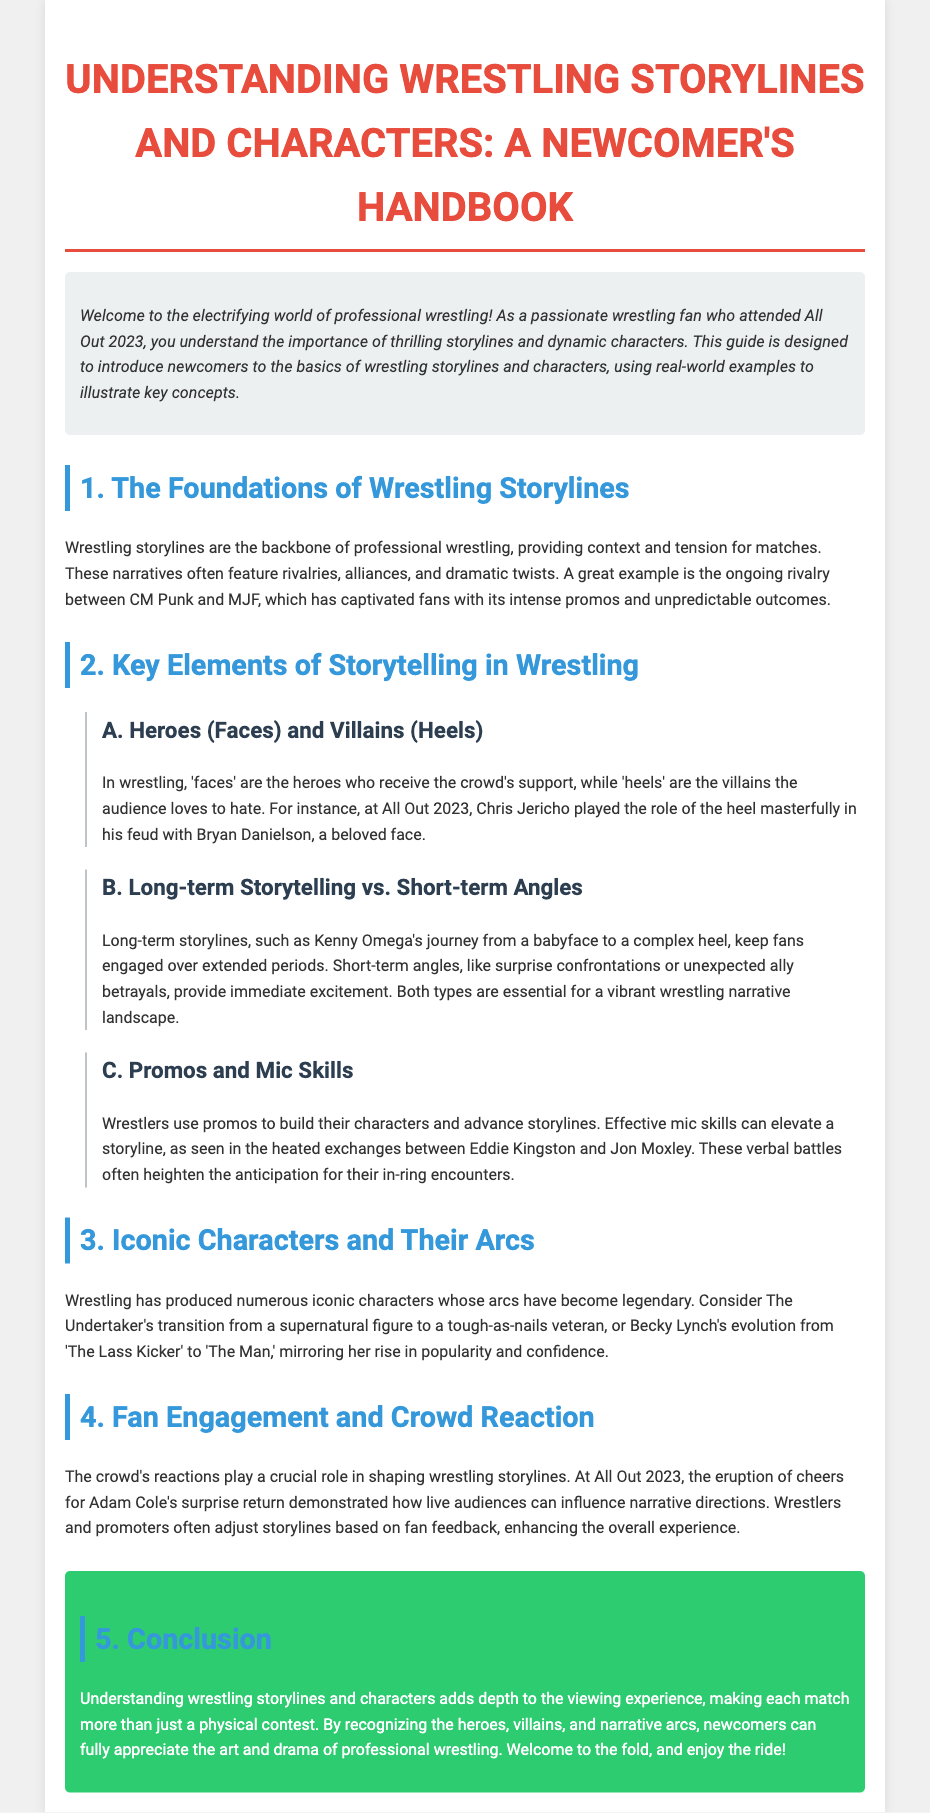What is the title of the handbook? The title of the handbook is stated at the beginning of the document, which provides a clear description of its purpose.
Answer: Understanding Wrestling Storylines and Characters: A Newcomer's Handbook Who are the authors of iconic characters mentioned? The document highlights specific iconic characters and their transformations, including two key figures.
Answer: The Undertaker and Becky Lynch What type of storytelling keeps fans engaged over extended periods? The document differentiates between two storytelling approaches, one of which emphasizes ongoing narrative engagement.
Answer: Long-term Storytelling Which wrestler's return was celebrated at All Out 2023? The document describes a key event during All Out 2023 where a specific wrestler received a significant audience reaction.
Answer: Adam Cole What is the primary role of 'heels' in wrestling? The document explains the roles of different character types in wrestling, specifically focusing on the antagonistic elements.
Answer: Villains What did Eddie Kingston and Jon Moxley use to heighten their storyline? The document refers to how certain communication techniques enhance character and plot development in wrestling narratives.
Answer: Promos What color is associated with the conclusion section? The document outlines the aesthetic aspects of formatted sections, specifically highlighting the conclusion's appearance.
Answer: Green How do wrestlers and promoters adjust storylines? The document mentions specific audience influences on narrative directions in wrestling, emphasizing an interactive relationship.
Answer: Based on fan feedback What is the purpose of this handbook? The introduction elaborates on the objectives of the handbook for newcomers to professional wrestling.
Answer: To introduce newcomers to the basics of wrestling storylines and characters 